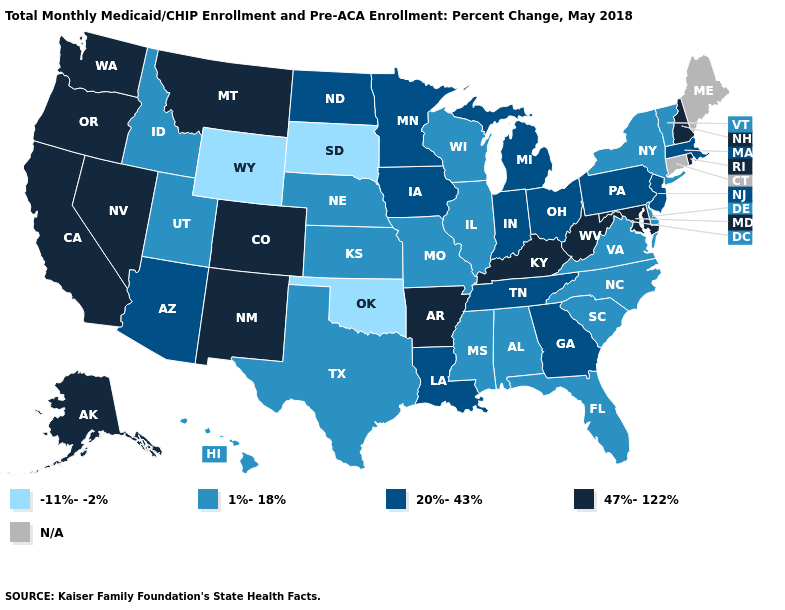What is the value of Oregon?
Give a very brief answer. 47%-122%. Is the legend a continuous bar?
Answer briefly. No. What is the value of New Hampshire?
Quick response, please. 47%-122%. What is the value of Georgia?
Be succinct. 20%-43%. What is the value of Colorado?
Be succinct. 47%-122%. Name the states that have a value in the range -11%--2%?
Keep it brief. Oklahoma, South Dakota, Wyoming. Among the states that border Ohio , does Indiana have the highest value?
Short answer required. No. Which states have the lowest value in the USA?
Give a very brief answer. Oklahoma, South Dakota, Wyoming. What is the value of Maryland?
Give a very brief answer. 47%-122%. Is the legend a continuous bar?
Quick response, please. No. Does the map have missing data?
Concise answer only. Yes. How many symbols are there in the legend?
Answer briefly. 5. What is the lowest value in the USA?
Give a very brief answer. -11%--2%. What is the highest value in the USA?
Keep it brief. 47%-122%. 